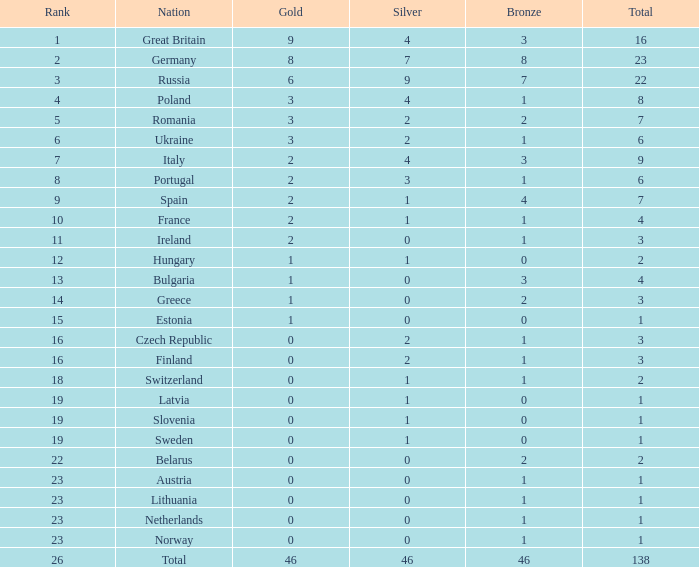When the overall amount is more than 1, and the bronze is below 3, and silver exceeds 2, and a gold surpasses 2, what is the nationality? Poland. 